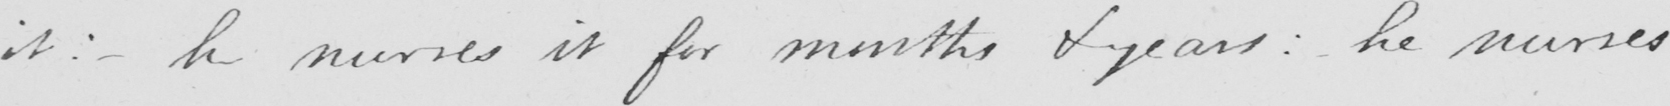What is written in this line of handwriting? it :   _  he nurses it for months & years :  he nurses 